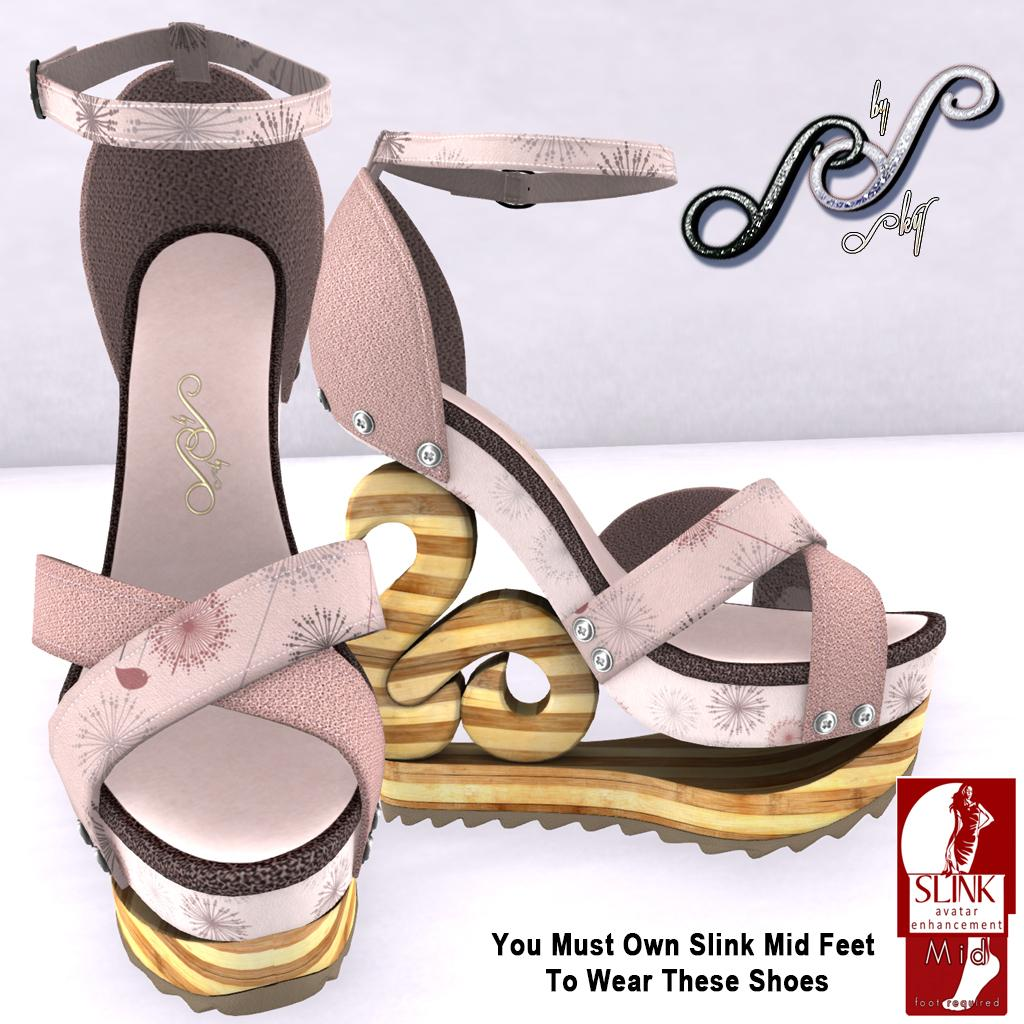What type of footwear is visible in the image? There is a pair of women's footwear in the image. Where is the text located in the image? The text is at the bottom right corner of the image. What brand or company might be associated with the image? The logo in the image might indicate the brand or company. How does the sister heal the wound in the image? There is no sister or wound present in the image. What type of cork is used to seal the bottle in the image? There is no bottle or cork present in the image. 